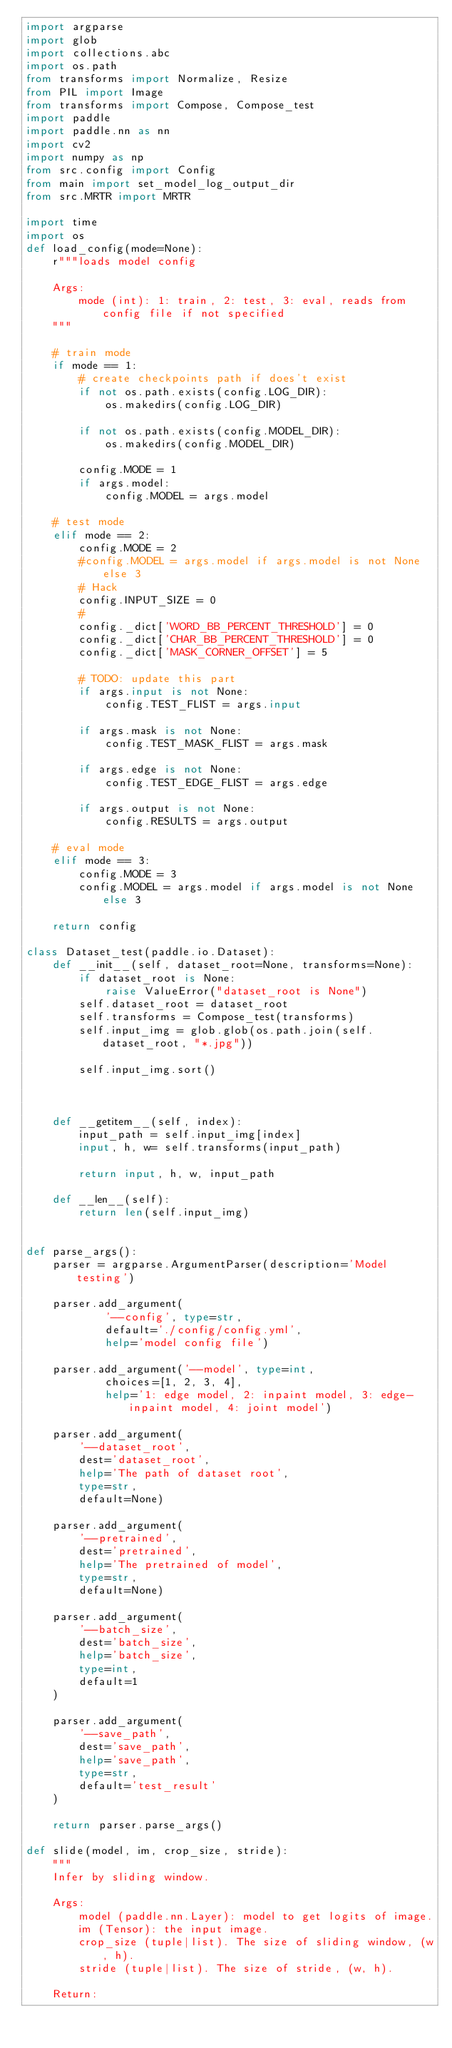<code> <loc_0><loc_0><loc_500><loc_500><_Python_>import argparse
import glob
import collections.abc
import os.path
from transforms import Normalize, Resize
from PIL import Image
from transforms import Compose, Compose_test
import paddle
import paddle.nn as nn
import cv2
import numpy as np
from src.config import Config
from main import set_model_log_output_dir
from src.MRTR import MRTR

import time
import os
def load_config(mode=None):
    r"""loads model config

    Args:
        mode (int): 1: train, 2: test, 3: eval, reads from config file if not specified
    """

    # train mode
    if mode == 1:
        # create checkpoints path if does't exist
        if not os.path.exists(config.LOG_DIR):
            os.makedirs(config.LOG_DIR)

        if not os.path.exists(config.MODEL_DIR):
            os.makedirs(config.MODEL_DIR)

        config.MODE = 1
        if args.model:
            config.MODEL = args.model

    # test mode
    elif mode == 2:
        config.MODE = 2
        #config.MODEL = args.model if args.model is not None else 3
        # Hack
        config.INPUT_SIZE = 0
        #
        config._dict['WORD_BB_PERCENT_THRESHOLD'] = 0
        config._dict['CHAR_BB_PERCENT_THRESHOLD'] = 0
        config._dict['MASK_CORNER_OFFSET'] = 5

        # TODO: update this part
        if args.input is not None:
            config.TEST_FLIST = args.input

        if args.mask is not None:
            config.TEST_MASK_FLIST = args.mask

        if args.edge is not None:
            config.TEST_EDGE_FLIST = args.edge

        if args.output is not None:
            config.RESULTS = args.output

    # eval mode
    elif mode == 3:
        config.MODE = 3
        config.MODEL = args.model if args.model is not None else 3

    return config

class Dataset_test(paddle.io.Dataset):
    def __init__(self, dataset_root=None, transforms=None):
        if dataset_root is None:
            raise ValueError("dataset_root is None")
        self.dataset_root = dataset_root
        self.transforms = Compose_test(transforms)
        self.input_img = glob.glob(os.path.join(self.dataset_root, "*.jpg"))

        self.input_img.sort()

 

    def __getitem__(self, index):
        input_path = self.input_img[index]  
        input, h, w= self.transforms(input_path)
        
        return input, h, w, input_path

    def __len__(self):
        return len(self.input_img)


def parse_args():
    parser = argparse.ArgumentParser(description='Model testing')

    parser.add_argument(
            '--config', type=str, 
            default='./config/config.yml', 
            help='model config file')

    parser.add_argument('--model', type=int, 
            choices=[1, 2, 3, 4], 
            help='1: edge model, 2: inpaint model, 3: edge-inpaint model, 4: joint model')

    parser.add_argument(
        '--dataset_root',
        dest='dataset_root',
        help='The path of dataset root',
        type=str,
        default=None)

    parser.add_argument(
        '--pretrained',
        dest='pretrained',
        help='The pretrained of model',
        type=str,
        default=None)

    parser.add_argument(
        '--batch_size',
        dest='batch_size',
        help='batch_size',
        type=int,
        default=1
    )

    parser.add_argument(
        '--save_path',
        dest='save_path',
        help='save_path',
        type=str,
        default='test_result'
    )

    return parser.parse_args()

def slide(model, im, crop_size, stride):
    """
    Infer by sliding window.

    Args:
        model (paddle.nn.Layer): model to get logits of image.
        im (Tensor): the input image.
        crop_size (tuple|list). The size of sliding window, (w, h).
        stride (tuple|list). The size of stride, (w, h).

    Return:</code> 